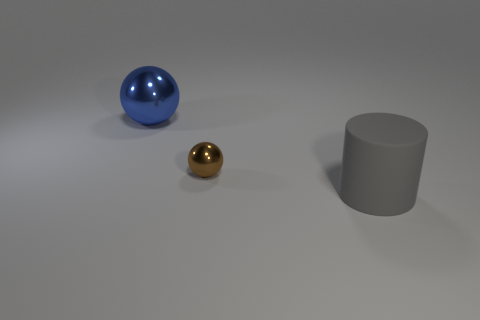Are there any other things that are the same size as the brown metal object?
Offer a terse response. No. How many big cyan rubber spheres are there?
Offer a terse response. 0. There is a big thing that is right of the large thing on the left side of the cylinder; what is its shape?
Offer a terse response. Cylinder. There is a tiny shiny thing; how many big gray matte cylinders are behind it?
Provide a succinct answer. 0. Is the material of the large cylinder the same as the large thing left of the matte cylinder?
Give a very brief answer. No. Are there any blue metal balls of the same size as the rubber thing?
Ensure brevity in your answer.  Yes. Are there an equal number of small spheres that are in front of the small shiny ball and big cyan metal things?
Your answer should be very brief. Yes. The blue metal thing has what size?
Make the answer very short. Large. How many rubber cylinders are behind the large thing behind the gray cylinder?
Provide a short and direct response. 0. How many big cylinders are the same color as the large shiny thing?
Offer a terse response. 0. 